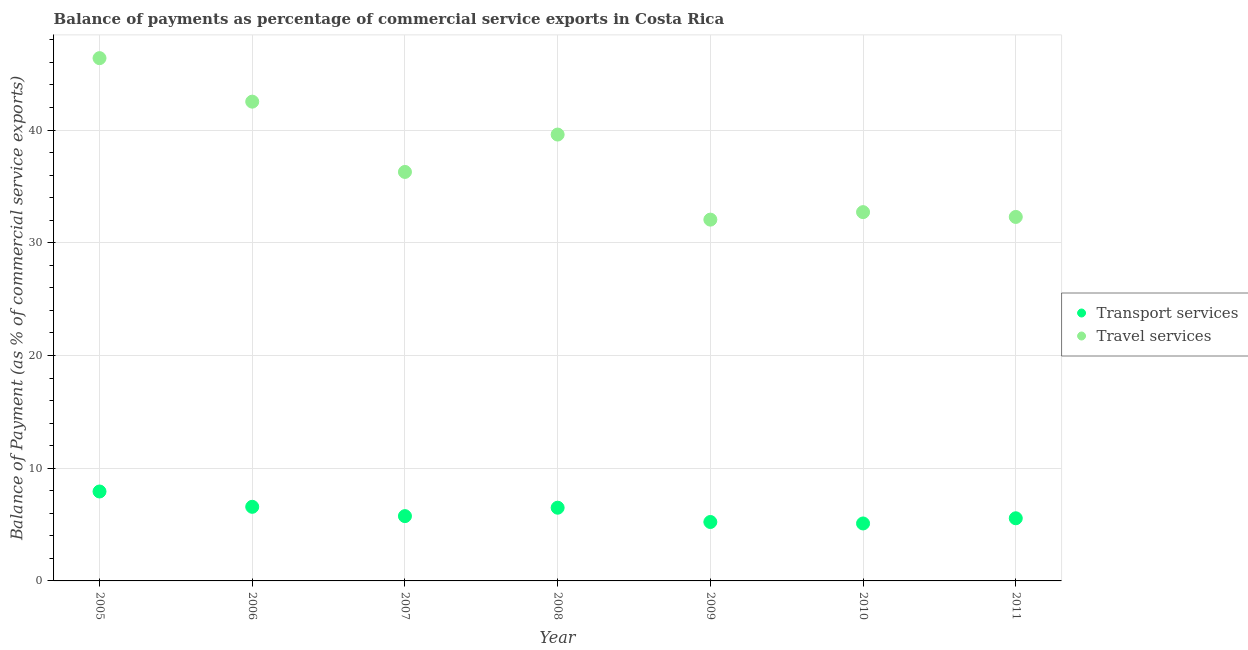What is the balance of payments of travel services in 2011?
Your answer should be very brief. 32.29. Across all years, what is the maximum balance of payments of transport services?
Make the answer very short. 7.93. Across all years, what is the minimum balance of payments of travel services?
Offer a very short reply. 32.05. What is the total balance of payments of travel services in the graph?
Provide a short and direct response. 261.84. What is the difference between the balance of payments of transport services in 2008 and that in 2009?
Provide a short and direct response. 1.27. What is the difference between the balance of payments of transport services in 2010 and the balance of payments of travel services in 2009?
Provide a short and direct response. -26.96. What is the average balance of payments of transport services per year?
Your answer should be very brief. 6.09. In the year 2006, what is the difference between the balance of payments of transport services and balance of payments of travel services?
Ensure brevity in your answer.  -35.94. What is the ratio of the balance of payments of travel services in 2005 to that in 2007?
Offer a terse response. 1.28. Is the balance of payments of transport services in 2006 less than that in 2007?
Give a very brief answer. No. What is the difference between the highest and the second highest balance of payments of transport services?
Provide a short and direct response. 1.36. What is the difference between the highest and the lowest balance of payments of transport services?
Give a very brief answer. 2.84. In how many years, is the balance of payments of travel services greater than the average balance of payments of travel services taken over all years?
Your response must be concise. 3. Is the balance of payments of transport services strictly greater than the balance of payments of travel services over the years?
Give a very brief answer. No. Is the balance of payments of transport services strictly less than the balance of payments of travel services over the years?
Make the answer very short. Yes. Does the graph contain any zero values?
Your answer should be very brief. No. Does the graph contain grids?
Give a very brief answer. Yes. How are the legend labels stacked?
Offer a terse response. Vertical. What is the title of the graph?
Give a very brief answer. Balance of payments as percentage of commercial service exports in Costa Rica. Does "Net savings(excluding particulate emission damage)" appear as one of the legend labels in the graph?
Your response must be concise. No. What is the label or title of the Y-axis?
Your response must be concise. Balance of Payment (as % of commercial service exports). What is the Balance of Payment (as % of commercial service exports) in Transport services in 2005?
Ensure brevity in your answer.  7.93. What is the Balance of Payment (as % of commercial service exports) in Travel services in 2005?
Provide a short and direct response. 46.38. What is the Balance of Payment (as % of commercial service exports) in Transport services in 2006?
Make the answer very short. 6.57. What is the Balance of Payment (as % of commercial service exports) in Travel services in 2006?
Offer a very short reply. 42.52. What is the Balance of Payment (as % of commercial service exports) of Transport services in 2007?
Keep it short and to the point. 5.75. What is the Balance of Payment (as % of commercial service exports) of Travel services in 2007?
Provide a succinct answer. 36.28. What is the Balance of Payment (as % of commercial service exports) of Transport services in 2008?
Provide a short and direct response. 6.5. What is the Balance of Payment (as % of commercial service exports) of Travel services in 2008?
Ensure brevity in your answer.  39.6. What is the Balance of Payment (as % of commercial service exports) of Transport services in 2009?
Ensure brevity in your answer.  5.23. What is the Balance of Payment (as % of commercial service exports) in Travel services in 2009?
Offer a terse response. 32.05. What is the Balance of Payment (as % of commercial service exports) of Transport services in 2010?
Make the answer very short. 5.1. What is the Balance of Payment (as % of commercial service exports) in Travel services in 2010?
Give a very brief answer. 32.72. What is the Balance of Payment (as % of commercial service exports) in Transport services in 2011?
Keep it short and to the point. 5.56. What is the Balance of Payment (as % of commercial service exports) of Travel services in 2011?
Make the answer very short. 32.29. Across all years, what is the maximum Balance of Payment (as % of commercial service exports) of Transport services?
Offer a terse response. 7.93. Across all years, what is the maximum Balance of Payment (as % of commercial service exports) in Travel services?
Make the answer very short. 46.38. Across all years, what is the minimum Balance of Payment (as % of commercial service exports) in Transport services?
Keep it short and to the point. 5.1. Across all years, what is the minimum Balance of Payment (as % of commercial service exports) in Travel services?
Offer a terse response. 32.05. What is the total Balance of Payment (as % of commercial service exports) in Transport services in the graph?
Offer a very short reply. 42.64. What is the total Balance of Payment (as % of commercial service exports) in Travel services in the graph?
Provide a succinct answer. 261.84. What is the difference between the Balance of Payment (as % of commercial service exports) in Transport services in 2005 and that in 2006?
Offer a terse response. 1.36. What is the difference between the Balance of Payment (as % of commercial service exports) of Travel services in 2005 and that in 2006?
Offer a terse response. 3.86. What is the difference between the Balance of Payment (as % of commercial service exports) of Transport services in 2005 and that in 2007?
Ensure brevity in your answer.  2.18. What is the difference between the Balance of Payment (as % of commercial service exports) of Travel services in 2005 and that in 2007?
Provide a short and direct response. 10.1. What is the difference between the Balance of Payment (as % of commercial service exports) in Transport services in 2005 and that in 2008?
Keep it short and to the point. 1.44. What is the difference between the Balance of Payment (as % of commercial service exports) of Travel services in 2005 and that in 2008?
Your answer should be compact. 6.78. What is the difference between the Balance of Payment (as % of commercial service exports) in Transport services in 2005 and that in 2009?
Your response must be concise. 2.71. What is the difference between the Balance of Payment (as % of commercial service exports) in Travel services in 2005 and that in 2009?
Your answer should be compact. 14.33. What is the difference between the Balance of Payment (as % of commercial service exports) in Transport services in 2005 and that in 2010?
Your response must be concise. 2.84. What is the difference between the Balance of Payment (as % of commercial service exports) in Travel services in 2005 and that in 2010?
Ensure brevity in your answer.  13.66. What is the difference between the Balance of Payment (as % of commercial service exports) of Transport services in 2005 and that in 2011?
Ensure brevity in your answer.  2.38. What is the difference between the Balance of Payment (as % of commercial service exports) of Travel services in 2005 and that in 2011?
Offer a very short reply. 14.09. What is the difference between the Balance of Payment (as % of commercial service exports) of Transport services in 2006 and that in 2007?
Your answer should be compact. 0.83. What is the difference between the Balance of Payment (as % of commercial service exports) of Travel services in 2006 and that in 2007?
Provide a succinct answer. 6.24. What is the difference between the Balance of Payment (as % of commercial service exports) in Transport services in 2006 and that in 2008?
Keep it short and to the point. 0.08. What is the difference between the Balance of Payment (as % of commercial service exports) of Travel services in 2006 and that in 2008?
Provide a succinct answer. 2.92. What is the difference between the Balance of Payment (as % of commercial service exports) of Transport services in 2006 and that in 2009?
Give a very brief answer. 1.35. What is the difference between the Balance of Payment (as % of commercial service exports) of Travel services in 2006 and that in 2009?
Keep it short and to the point. 10.47. What is the difference between the Balance of Payment (as % of commercial service exports) in Transport services in 2006 and that in 2010?
Provide a short and direct response. 1.48. What is the difference between the Balance of Payment (as % of commercial service exports) in Travel services in 2006 and that in 2010?
Offer a very short reply. 9.8. What is the difference between the Balance of Payment (as % of commercial service exports) of Transport services in 2006 and that in 2011?
Your response must be concise. 1.02. What is the difference between the Balance of Payment (as % of commercial service exports) of Travel services in 2006 and that in 2011?
Your answer should be compact. 10.23. What is the difference between the Balance of Payment (as % of commercial service exports) of Transport services in 2007 and that in 2008?
Keep it short and to the point. -0.75. What is the difference between the Balance of Payment (as % of commercial service exports) of Travel services in 2007 and that in 2008?
Provide a short and direct response. -3.32. What is the difference between the Balance of Payment (as % of commercial service exports) in Transport services in 2007 and that in 2009?
Offer a terse response. 0.52. What is the difference between the Balance of Payment (as % of commercial service exports) in Travel services in 2007 and that in 2009?
Give a very brief answer. 4.23. What is the difference between the Balance of Payment (as % of commercial service exports) in Transport services in 2007 and that in 2010?
Ensure brevity in your answer.  0.65. What is the difference between the Balance of Payment (as % of commercial service exports) in Travel services in 2007 and that in 2010?
Keep it short and to the point. 3.57. What is the difference between the Balance of Payment (as % of commercial service exports) in Transport services in 2007 and that in 2011?
Give a very brief answer. 0.19. What is the difference between the Balance of Payment (as % of commercial service exports) in Travel services in 2007 and that in 2011?
Provide a succinct answer. 3.99. What is the difference between the Balance of Payment (as % of commercial service exports) in Transport services in 2008 and that in 2009?
Provide a succinct answer. 1.27. What is the difference between the Balance of Payment (as % of commercial service exports) of Travel services in 2008 and that in 2009?
Make the answer very short. 7.55. What is the difference between the Balance of Payment (as % of commercial service exports) in Transport services in 2008 and that in 2010?
Offer a terse response. 1.4. What is the difference between the Balance of Payment (as % of commercial service exports) of Travel services in 2008 and that in 2010?
Provide a short and direct response. 6.88. What is the difference between the Balance of Payment (as % of commercial service exports) in Travel services in 2008 and that in 2011?
Your answer should be very brief. 7.31. What is the difference between the Balance of Payment (as % of commercial service exports) in Transport services in 2009 and that in 2010?
Your answer should be very brief. 0.13. What is the difference between the Balance of Payment (as % of commercial service exports) in Travel services in 2009 and that in 2010?
Give a very brief answer. -0.66. What is the difference between the Balance of Payment (as % of commercial service exports) of Transport services in 2009 and that in 2011?
Give a very brief answer. -0.33. What is the difference between the Balance of Payment (as % of commercial service exports) of Travel services in 2009 and that in 2011?
Provide a short and direct response. -0.24. What is the difference between the Balance of Payment (as % of commercial service exports) in Transport services in 2010 and that in 2011?
Your answer should be compact. -0.46. What is the difference between the Balance of Payment (as % of commercial service exports) in Travel services in 2010 and that in 2011?
Offer a terse response. 0.43. What is the difference between the Balance of Payment (as % of commercial service exports) of Transport services in 2005 and the Balance of Payment (as % of commercial service exports) of Travel services in 2006?
Give a very brief answer. -34.59. What is the difference between the Balance of Payment (as % of commercial service exports) in Transport services in 2005 and the Balance of Payment (as % of commercial service exports) in Travel services in 2007?
Offer a terse response. -28.35. What is the difference between the Balance of Payment (as % of commercial service exports) of Transport services in 2005 and the Balance of Payment (as % of commercial service exports) of Travel services in 2008?
Your answer should be compact. -31.67. What is the difference between the Balance of Payment (as % of commercial service exports) in Transport services in 2005 and the Balance of Payment (as % of commercial service exports) in Travel services in 2009?
Keep it short and to the point. -24.12. What is the difference between the Balance of Payment (as % of commercial service exports) of Transport services in 2005 and the Balance of Payment (as % of commercial service exports) of Travel services in 2010?
Your response must be concise. -24.78. What is the difference between the Balance of Payment (as % of commercial service exports) in Transport services in 2005 and the Balance of Payment (as % of commercial service exports) in Travel services in 2011?
Provide a succinct answer. -24.36. What is the difference between the Balance of Payment (as % of commercial service exports) of Transport services in 2006 and the Balance of Payment (as % of commercial service exports) of Travel services in 2007?
Ensure brevity in your answer.  -29.71. What is the difference between the Balance of Payment (as % of commercial service exports) in Transport services in 2006 and the Balance of Payment (as % of commercial service exports) in Travel services in 2008?
Your answer should be compact. -33.03. What is the difference between the Balance of Payment (as % of commercial service exports) of Transport services in 2006 and the Balance of Payment (as % of commercial service exports) of Travel services in 2009?
Make the answer very short. -25.48. What is the difference between the Balance of Payment (as % of commercial service exports) of Transport services in 2006 and the Balance of Payment (as % of commercial service exports) of Travel services in 2010?
Your answer should be very brief. -26.14. What is the difference between the Balance of Payment (as % of commercial service exports) of Transport services in 2006 and the Balance of Payment (as % of commercial service exports) of Travel services in 2011?
Offer a terse response. -25.72. What is the difference between the Balance of Payment (as % of commercial service exports) of Transport services in 2007 and the Balance of Payment (as % of commercial service exports) of Travel services in 2008?
Provide a succinct answer. -33.85. What is the difference between the Balance of Payment (as % of commercial service exports) in Transport services in 2007 and the Balance of Payment (as % of commercial service exports) in Travel services in 2009?
Ensure brevity in your answer.  -26.3. What is the difference between the Balance of Payment (as % of commercial service exports) of Transport services in 2007 and the Balance of Payment (as % of commercial service exports) of Travel services in 2010?
Your answer should be very brief. -26.97. What is the difference between the Balance of Payment (as % of commercial service exports) of Transport services in 2007 and the Balance of Payment (as % of commercial service exports) of Travel services in 2011?
Make the answer very short. -26.54. What is the difference between the Balance of Payment (as % of commercial service exports) of Transport services in 2008 and the Balance of Payment (as % of commercial service exports) of Travel services in 2009?
Your answer should be compact. -25.56. What is the difference between the Balance of Payment (as % of commercial service exports) in Transport services in 2008 and the Balance of Payment (as % of commercial service exports) in Travel services in 2010?
Your answer should be very brief. -26.22. What is the difference between the Balance of Payment (as % of commercial service exports) of Transport services in 2008 and the Balance of Payment (as % of commercial service exports) of Travel services in 2011?
Offer a very short reply. -25.8. What is the difference between the Balance of Payment (as % of commercial service exports) in Transport services in 2009 and the Balance of Payment (as % of commercial service exports) in Travel services in 2010?
Give a very brief answer. -27.49. What is the difference between the Balance of Payment (as % of commercial service exports) in Transport services in 2009 and the Balance of Payment (as % of commercial service exports) in Travel services in 2011?
Keep it short and to the point. -27.06. What is the difference between the Balance of Payment (as % of commercial service exports) of Transport services in 2010 and the Balance of Payment (as % of commercial service exports) of Travel services in 2011?
Make the answer very short. -27.19. What is the average Balance of Payment (as % of commercial service exports) of Transport services per year?
Offer a terse response. 6.09. What is the average Balance of Payment (as % of commercial service exports) in Travel services per year?
Keep it short and to the point. 37.41. In the year 2005, what is the difference between the Balance of Payment (as % of commercial service exports) of Transport services and Balance of Payment (as % of commercial service exports) of Travel services?
Ensure brevity in your answer.  -38.45. In the year 2006, what is the difference between the Balance of Payment (as % of commercial service exports) in Transport services and Balance of Payment (as % of commercial service exports) in Travel services?
Offer a very short reply. -35.94. In the year 2007, what is the difference between the Balance of Payment (as % of commercial service exports) of Transport services and Balance of Payment (as % of commercial service exports) of Travel services?
Provide a succinct answer. -30.53. In the year 2008, what is the difference between the Balance of Payment (as % of commercial service exports) in Transport services and Balance of Payment (as % of commercial service exports) in Travel services?
Keep it short and to the point. -33.1. In the year 2009, what is the difference between the Balance of Payment (as % of commercial service exports) of Transport services and Balance of Payment (as % of commercial service exports) of Travel services?
Offer a very short reply. -26.82. In the year 2010, what is the difference between the Balance of Payment (as % of commercial service exports) of Transport services and Balance of Payment (as % of commercial service exports) of Travel services?
Provide a succinct answer. -27.62. In the year 2011, what is the difference between the Balance of Payment (as % of commercial service exports) in Transport services and Balance of Payment (as % of commercial service exports) in Travel services?
Make the answer very short. -26.73. What is the ratio of the Balance of Payment (as % of commercial service exports) of Transport services in 2005 to that in 2006?
Ensure brevity in your answer.  1.21. What is the ratio of the Balance of Payment (as % of commercial service exports) in Travel services in 2005 to that in 2006?
Your response must be concise. 1.09. What is the ratio of the Balance of Payment (as % of commercial service exports) of Transport services in 2005 to that in 2007?
Your answer should be compact. 1.38. What is the ratio of the Balance of Payment (as % of commercial service exports) of Travel services in 2005 to that in 2007?
Offer a terse response. 1.28. What is the ratio of the Balance of Payment (as % of commercial service exports) of Transport services in 2005 to that in 2008?
Make the answer very short. 1.22. What is the ratio of the Balance of Payment (as % of commercial service exports) in Travel services in 2005 to that in 2008?
Ensure brevity in your answer.  1.17. What is the ratio of the Balance of Payment (as % of commercial service exports) in Transport services in 2005 to that in 2009?
Your answer should be very brief. 1.52. What is the ratio of the Balance of Payment (as % of commercial service exports) in Travel services in 2005 to that in 2009?
Your answer should be very brief. 1.45. What is the ratio of the Balance of Payment (as % of commercial service exports) in Transport services in 2005 to that in 2010?
Ensure brevity in your answer.  1.56. What is the ratio of the Balance of Payment (as % of commercial service exports) in Travel services in 2005 to that in 2010?
Keep it short and to the point. 1.42. What is the ratio of the Balance of Payment (as % of commercial service exports) of Transport services in 2005 to that in 2011?
Ensure brevity in your answer.  1.43. What is the ratio of the Balance of Payment (as % of commercial service exports) in Travel services in 2005 to that in 2011?
Your response must be concise. 1.44. What is the ratio of the Balance of Payment (as % of commercial service exports) in Transport services in 2006 to that in 2007?
Offer a very short reply. 1.14. What is the ratio of the Balance of Payment (as % of commercial service exports) in Travel services in 2006 to that in 2007?
Your response must be concise. 1.17. What is the ratio of the Balance of Payment (as % of commercial service exports) in Transport services in 2006 to that in 2008?
Offer a terse response. 1.01. What is the ratio of the Balance of Payment (as % of commercial service exports) in Travel services in 2006 to that in 2008?
Offer a terse response. 1.07. What is the ratio of the Balance of Payment (as % of commercial service exports) of Transport services in 2006 to that in 2009?
Provide a short and direct response. 1.26. What is the ratio of the Balance of Payment (as % of commercial service exports) in Travel services in 2006 to that in 2009?
Offer a very short reply. 1.33. What is the ratio of the Balance of Payment (as % of commercial service exports) in Transport services in 2006 to that in 2010?
Ensure brevity in your answer.  1.29. What is the ratio of the Balance of Payment (as % of commercial service exports) in Travel services in 2006 to that in 2010?
Give a very brief answer. 1.3. What is the ratio of the Balance of Payment (as % of commercial service exports) in Transport services in 2006 to that in 2011?
Your answer should be compact. 1.18. What is the ratio of the Balance of Payment (as % of commercial service exports) in Travel services in 2006 to that in 2011?
Your answer should be very brief. 1.32. What is the ratio of the Balance of Payment (as % of commercial service exports) in Transport services in 2007 to that in 2008?
Your response must be concise. 0.89. What is the ratio of the Balance of Payment (as % of commercial service exports) in Travel services in 2007 to that in 2008?
Your answer should be compact. 0.92. What is the ratio of the Balance of Payment (as % of commercial service exports) of Transport services in 2007 to that in 2009?
Ensure brevity in your answer.  1.1. What is the ratio of the Balance of Payment (as % of commercial service exports) of Travel services in 2007 to that in 2009?
Offer a terse response. 1.13. What is the ratio of the Balance of Payment (as % of commercial service exports) in Transport services in 2007 to that in 2010?
Keep it short and to the point. 1.13. What is the ratio of the Balance of Payment (as % of commercial service exports) in Travel services in 2007 to that in 2010?
Your answer should be very brief. 1.11. What is the ratio of the Balance of Payment (as % of commercial service exports) in Transport services in 2007 to that in 2011?
Provide a short and direct response. 1.03. What is the ratio of the Balance of Payment (as % of commercial service exports) in Travel services in 2007 to that in 2011?
Offer a very short reply. 1.12. What is the ratio of the Balance of Payment (as % of commercial service exports) of Transport services in 2008 to that in 2009?
Your answer should be very brief. 1.24. What is the ratio of the Balance of Payment (as % of commercial service exports) of Travel services in 2008 to that in 2009?
Your answer should be compact. 1.24. What is the ratio of the Balance of Payment (as % of commercial service exports) in Transport services in 2008 to that in 2010?
Your answer should be compact. 1.27. What is the ratio of the Balance of Payment (as % of commercial service exports) of Travel services in 2008 to that in 2010?
Your answer should be compact. 1.21. What is the ratio of the Balance of Payment (as % of commercial service exports) in Transport services in 2008 to that in 2011?
Offer a terse response. 1.17. What is the ratio of the Balance of Payment (as % of commercial service exports) of Travel services in 2008 to that in 2011?
Make the answer very short. 1.23. What is the ratio of the Balance of Payment (as % of commercial service exports) in Transport services in 2009 to that in 2010?
Provide a short and direct response. 1.03. What is the ratio of the Balance of Payment (as % of commercial service exports) of Travel services in 2009 to that in 2010?
Ensure brevity in your answer.  0.98. What is the ratio of the Balance of Payment (as % of commercial service exports) of Transport services in 2009 to that in 2011?
Keep it short and to the point. 0.94. What is the ratio of the Balance of Payment (as % of commercial service exports) in Transport services in 2010 to that in 2011?
Ensure brevity in your answer.  0.92. What is the ratio of the Balance of Payment (as % of commercial service exports) in Travel services in 2010 to that in 2011?
Keep it short and to the point. 1.01. What is the difference between the highest and the second highest Balance of Payment (as % of commercial service exports) in Transport services?
Provide a succinct answer. 1.36. What is the difference between the highest and the second highest Balance of Payment (as % of commercial service exports) in Travel services?
Your answer should be compact. 3.86. What is the difference between the highest and the lowest Balance of Payment (as % of commercial service exports) in Transport services?
Your answer should be very brief. 2.84. What is the difference between the highest and the lowest Balance of Payment (as % of commercial service exports) of Travel services?
Your answer should be very brief. 14.33. 